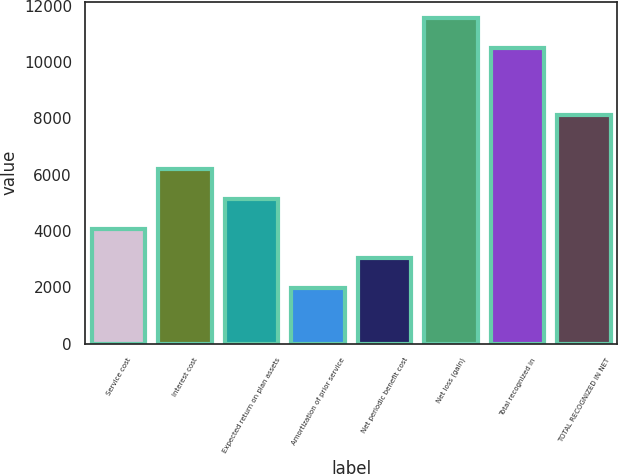Convert chart to OTSL. <chart><loc_0><loc_0><loc_500><loc_500><bar_chart><fcel>Service cost<fcel>Interest cost<fcel>Expected return on plan assets<fcel>Amortization of prior service<fcel>Net periodic benefit cost<fcel>Net loss (gain)<fcel>Total recognized in<fcel>TOTAL RECOGNIZED IN NET<nl><fcel>4087.8<fcel>6191<fcel>5139.4<fcel>1984.6<fcel>3036.2<fcel>11567.6<fcel>10516<fcel>8111<nl></chart> 